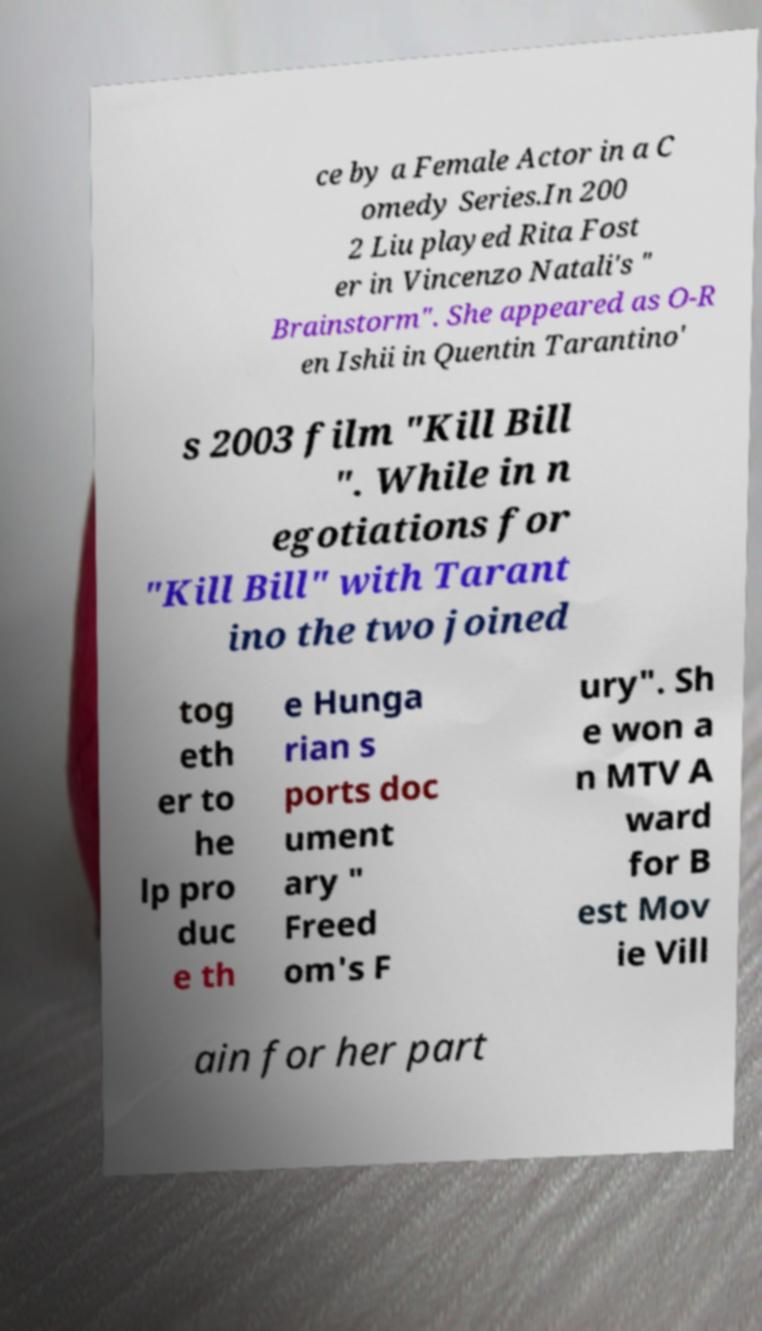I need the written content from this picture converted into text. Can you do that? ce by a Female Actor in a C omedy Series.In 200 2 Liu played Rita Fost er in Vincenzo Natali's " Brainstorm". She appeared as O-R en Ishii in Quentin Tarantino' s 2003 film "Kill Bill ". While in n egotiations for "Kill Bill" with Tarant ino the two joined tog eth er to he lp pro duc e th e Hunga rian s ports doc ument ary " Freed om's F ury". Sh e won a n MTV A ward for B est Mov ie Vill ain for her part 